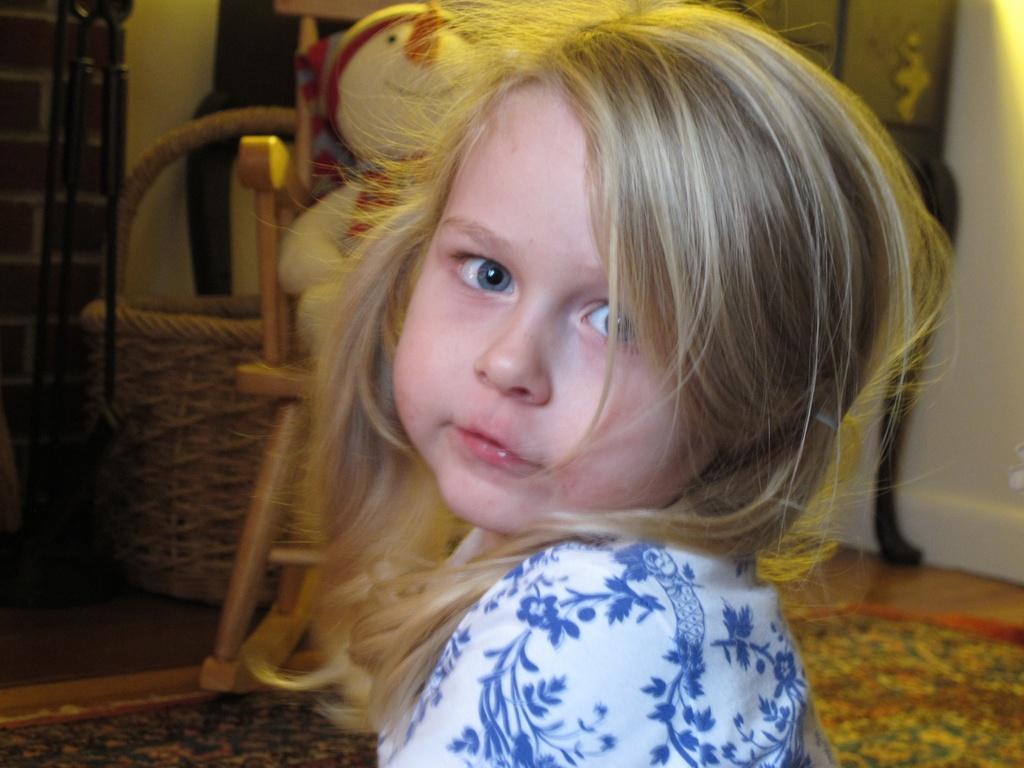In one or two sentences, can you explain what this image depicts? In the picture I can see a kid wearing white and blue color dress and there is a doll placed on the chair behind her and there are some other objects in the background. 